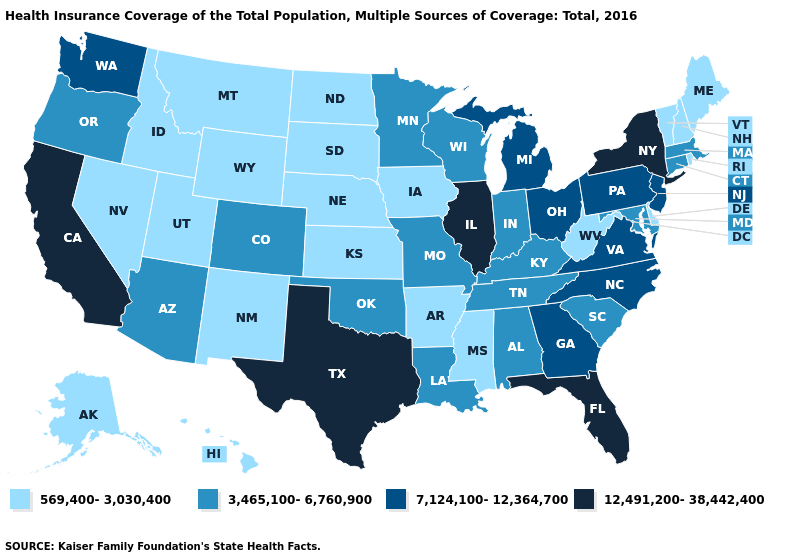Is the legend a continuous bar?
Give a very brief answer. No. Among the states that border Utah , which have the lowest value?
Keep it brief. Idaho, Nevada, New Mexico, Wyoming. Does the first symbol in the legend represent the smallest category?
Keep it brief. Yes. What is the highest value in states that border Connecticut?
Quick response, please. 12,491,200-38,442,400. Which states have the lowest value in the West?
Be succinct. Alaska, Hawaii, Idaho, Montana, Nevada, New Mexico, Utah, Wyoming. Among the states that border Kansas , does Colorado have the lowest value?
Short answer required. No. What is the highest value in states that border Connecticut?
Write a very short answer. 12,491,200-38,442,400. Does Vermont have a higher value than Georgia?
Give a very brief answer. No. What is the value of Minnesota?
Concise answer only. 3,465,100-6,760,900. Does West Virginia have a lower value than Maine?
Quick response, please. No. Is the legend a continuous bar?
Write a very short answer. No. What is the value of Virginia?
Quick response, please. 7,124,100-12,364,700. Name the states that have a value in the range 3,465,100-6,760,900?
Write a very short answer. Alabama, Arizona, Colorado, Connecticut, Indiana, Kentucky, Louisiana, Maryland, Massachusetts, Minnesota, Missouri, Oklahoma, Oregon, South Carolina, Tennessee, Wisconsin. What is the value of New Jersey?
Give a very brief answer. 7,124,100-12,364,700. What is the value of Oklahoma?
Be succinct. 3,465,100-6,760,900. 